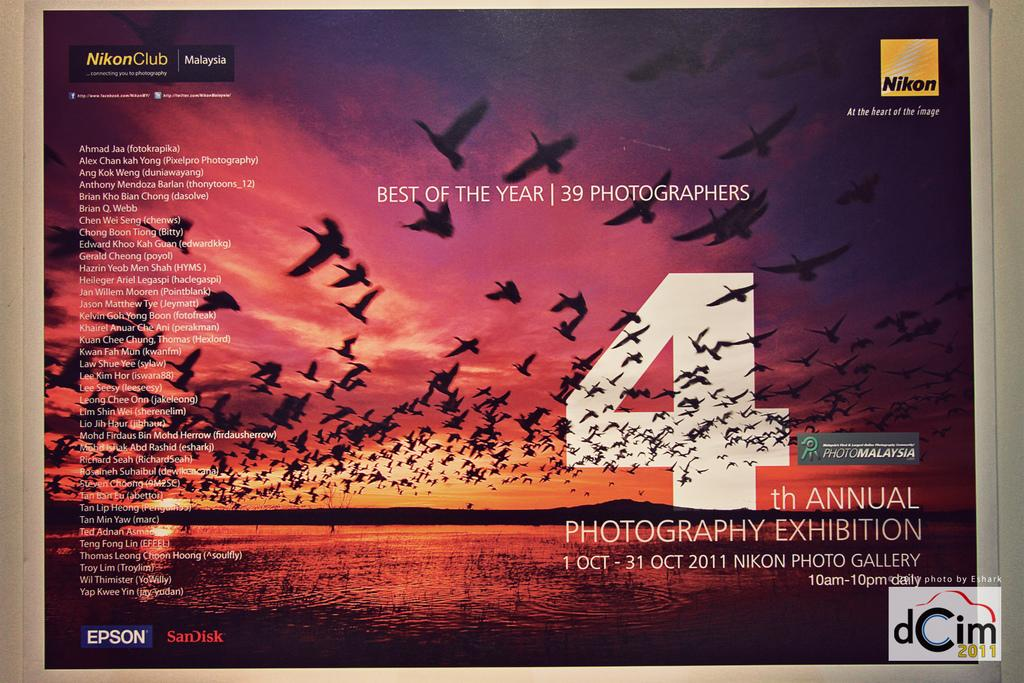<image>
Offer a succinct explanation of the picture presented. A flyer for the 4th annual photography exhibition that is sponsored by Epson, Scandisk, and Nikon. 